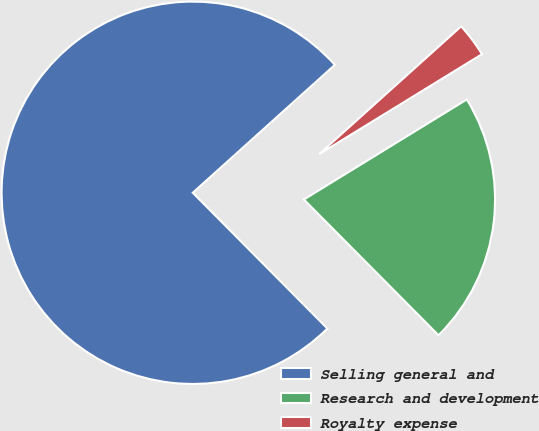Convert chart. <chart><loc_0><loc_0><loc_500><loc_500><pie_chart><fcel>Selling general and<fcel>Research and development<fcel>Royalty expense<nl><fcel>75.77%<fcel>21.33%<fcel>2.9%<nl></chart> 